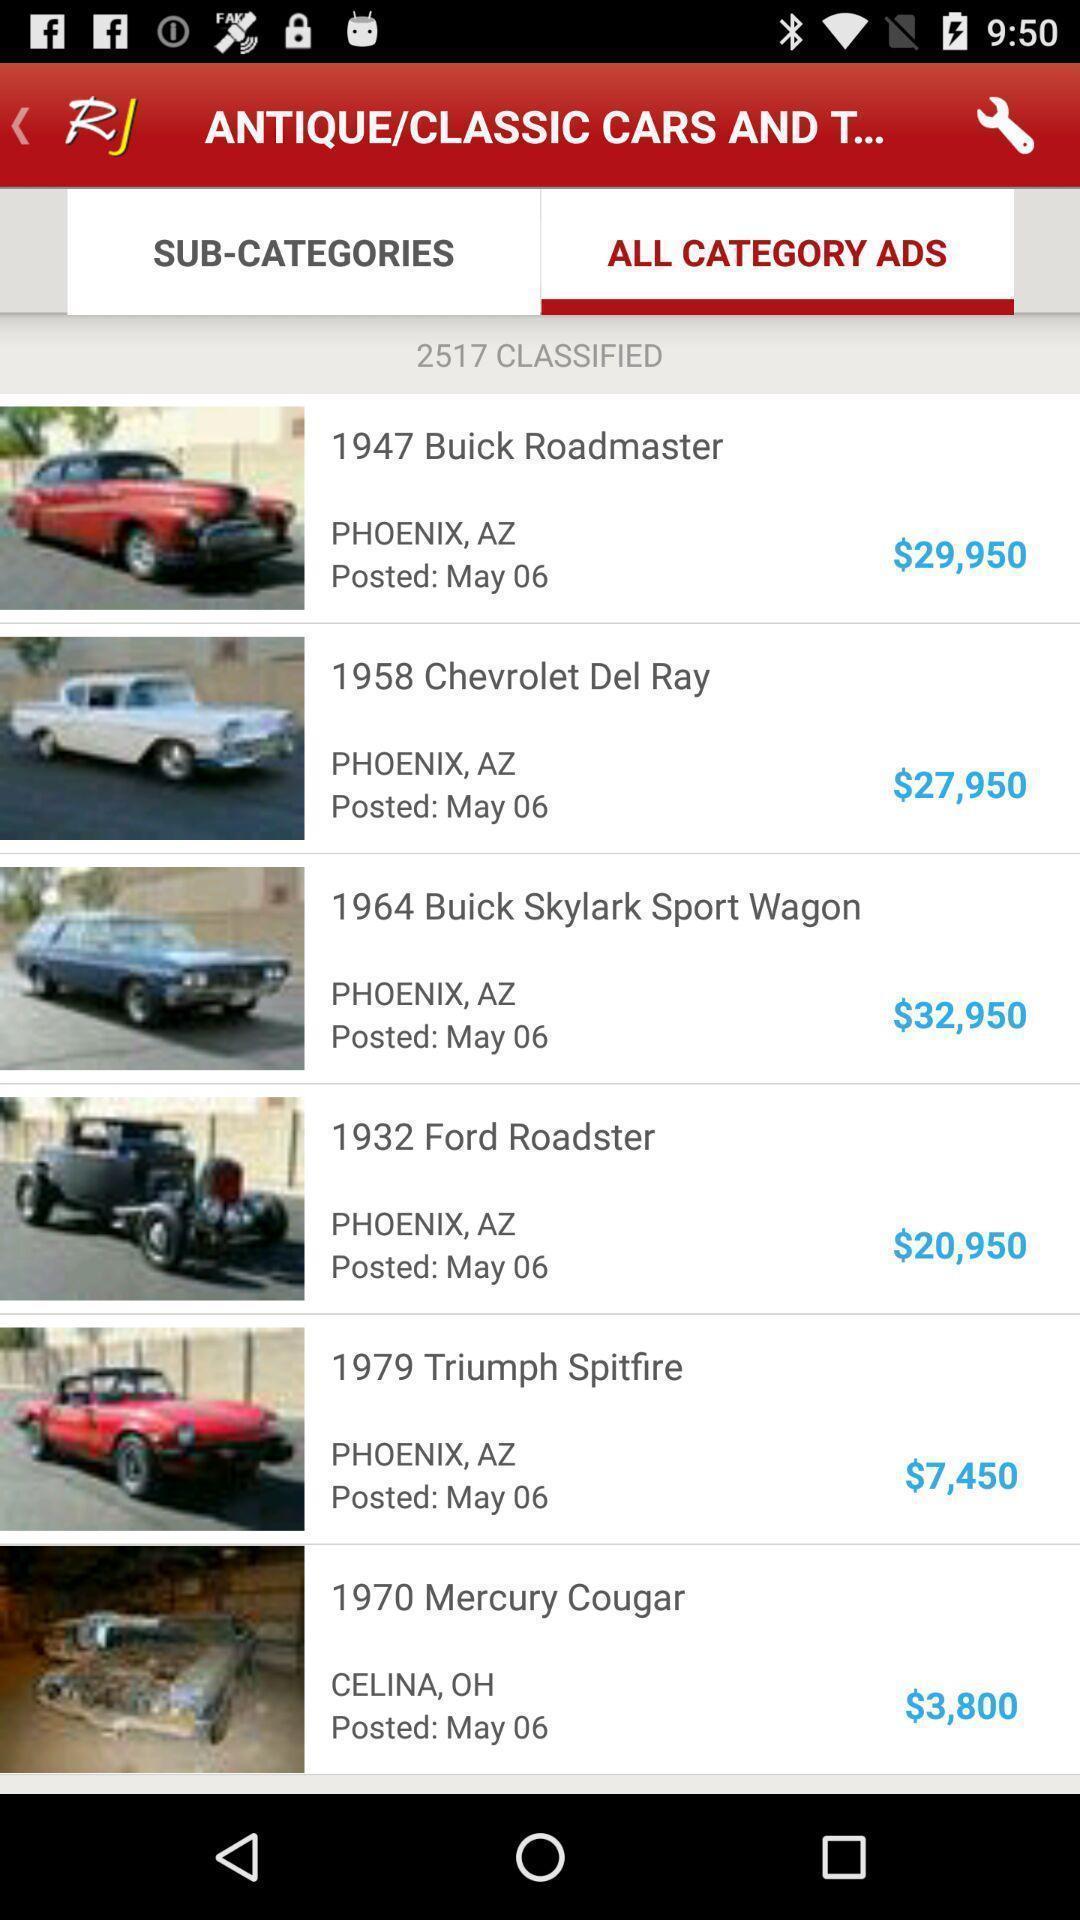Please provide a description for this image. Screen showing categories. 